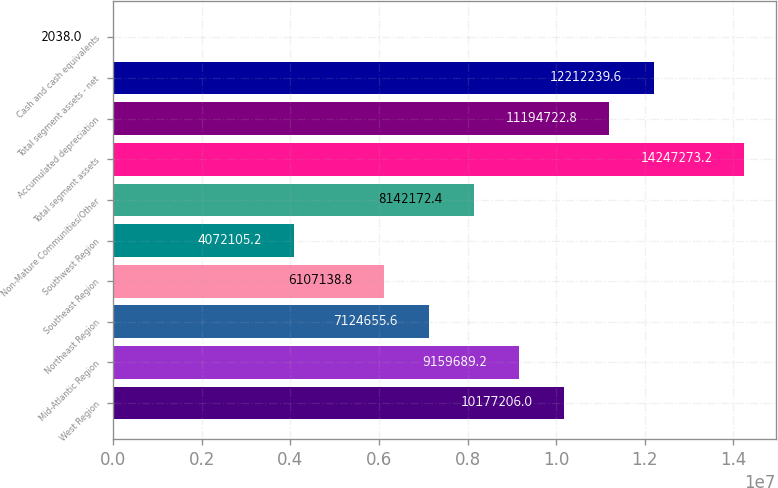Convert chart. <chart><loc_0><loc_0><loc_500><loc_500><bar_chart><fcel>West Region<fcel>Mid-Atlantic Region<fcel>Northeast Region<fcel>Southeast Region<fcel>Southwest Region<fcel>Non-Mature Communities/Other<fcel>Total segment assets<fcel>Accumulated depreciation<fcel>Total segment assets - net<fcel>Cash and cash equivalents<nl><fcel>1.01772e+07<fcel>9.15969e+06<fcel>7.12466e+06<fcel>6.10714e+06<fcel>4.07211e+06<fcel>8.14217e+06<fcel>1.42473e+07<fcel>1.11947e+07<fcel>1.22122e+07<fcel>2038<nl></chart> 